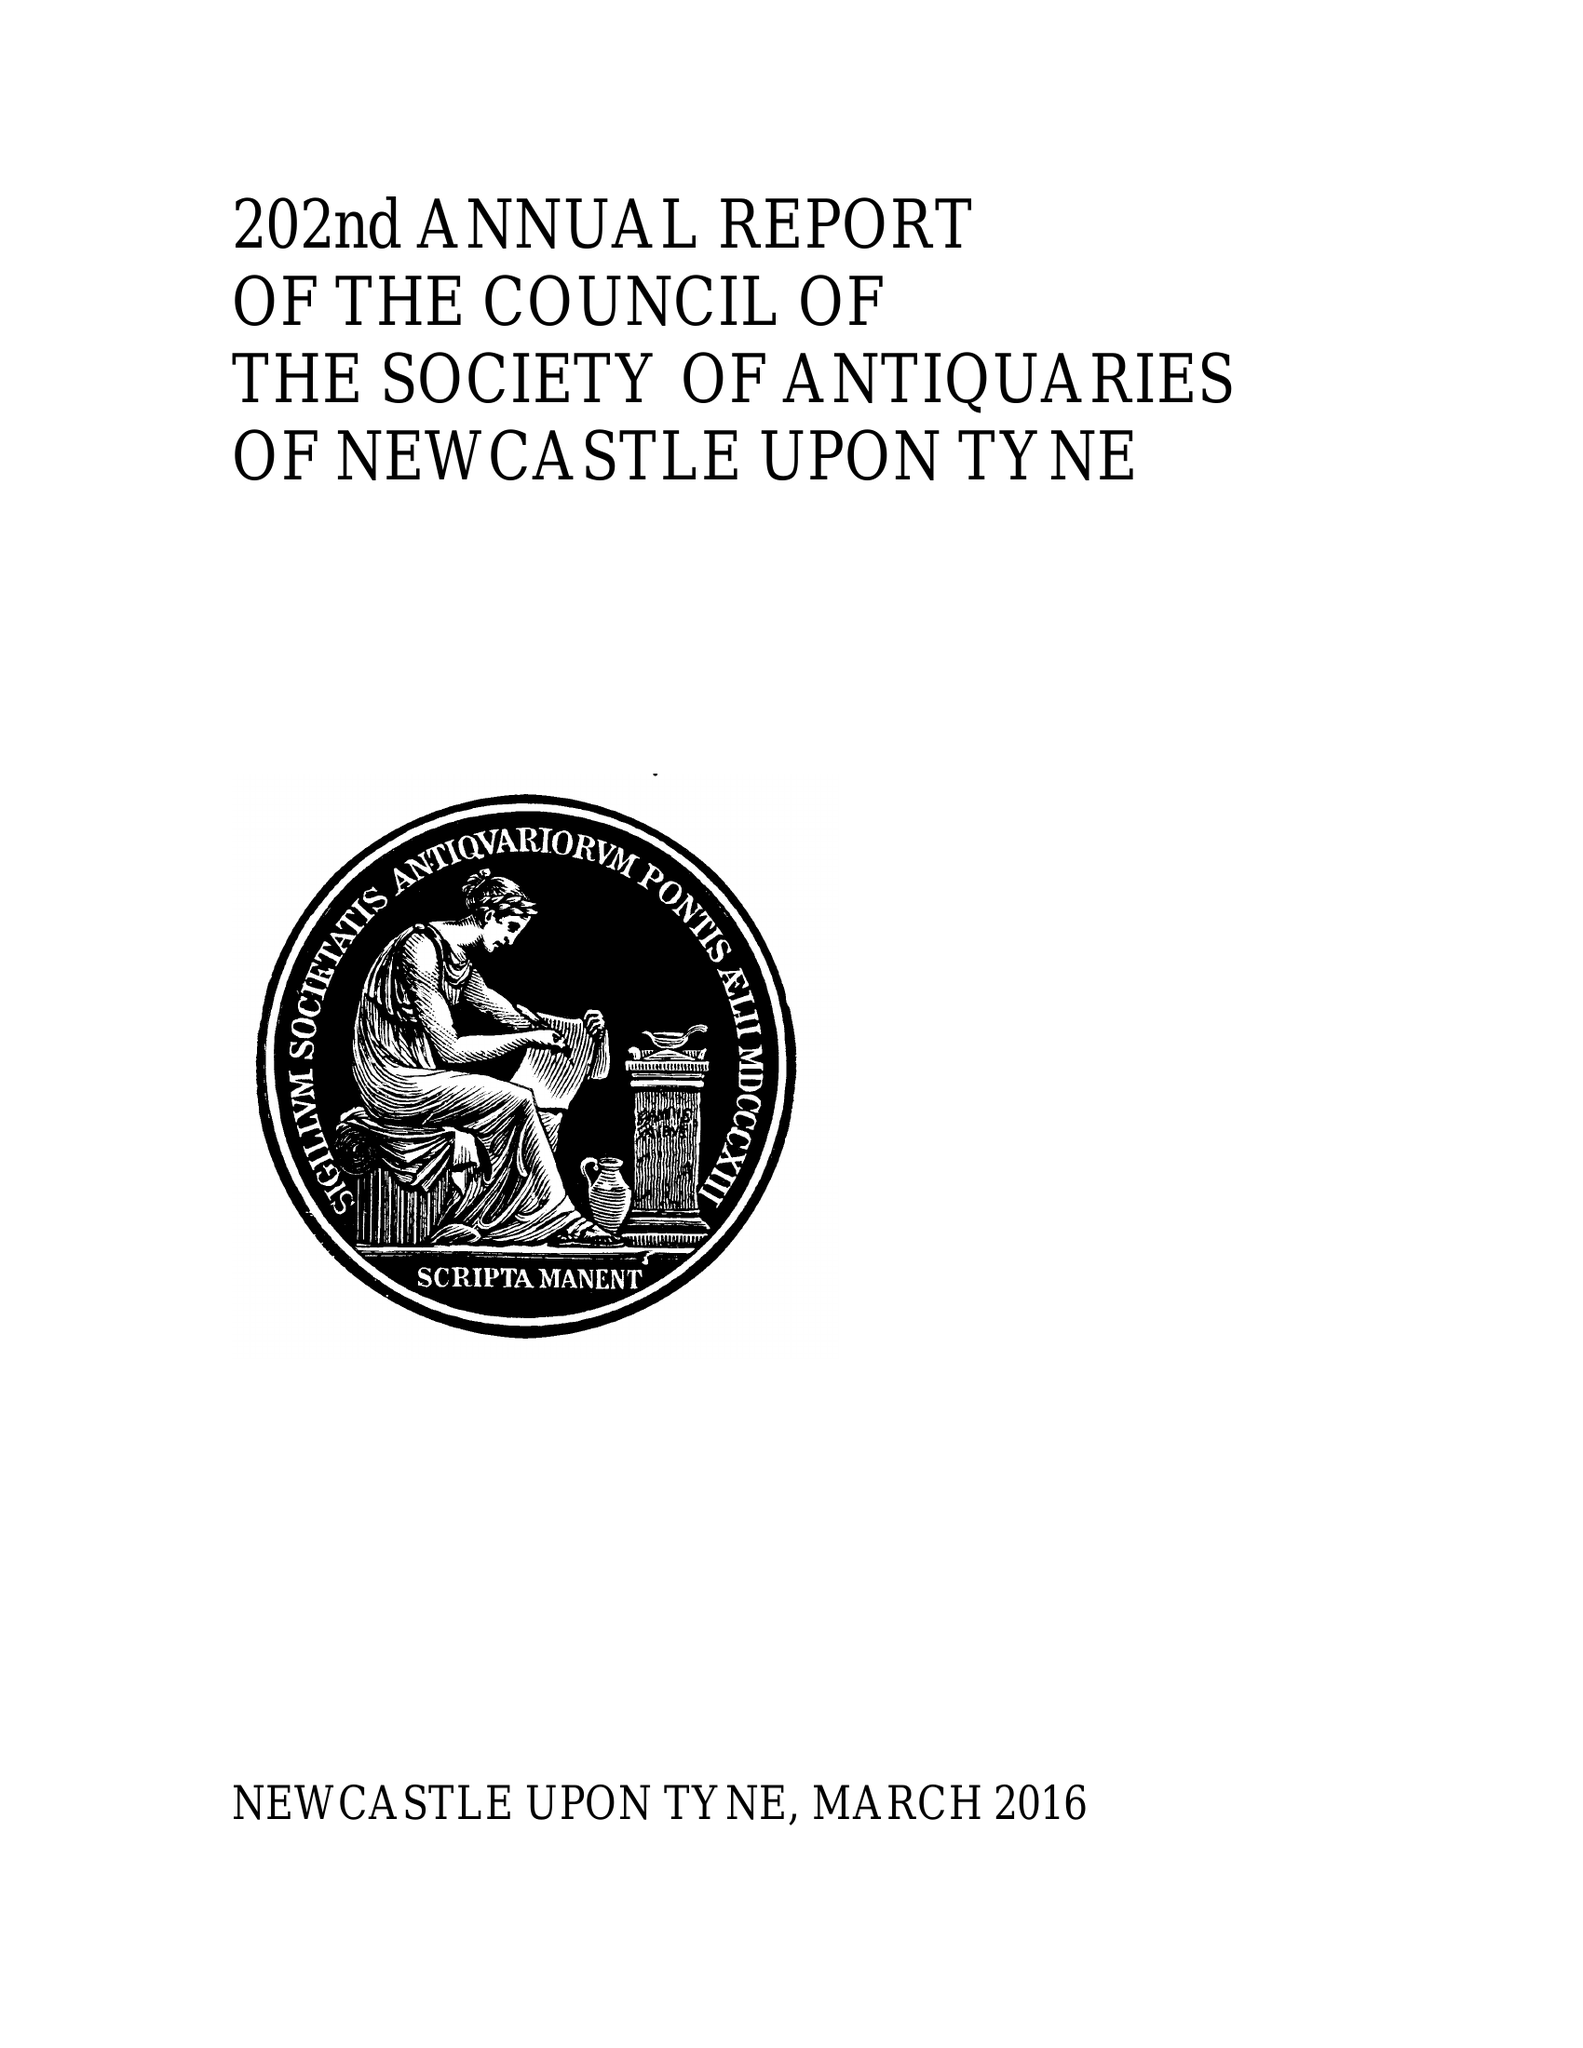What is the value for the spending_annually_in_british_pounds?
Answer the question using a single word or phrase. 69436.00 